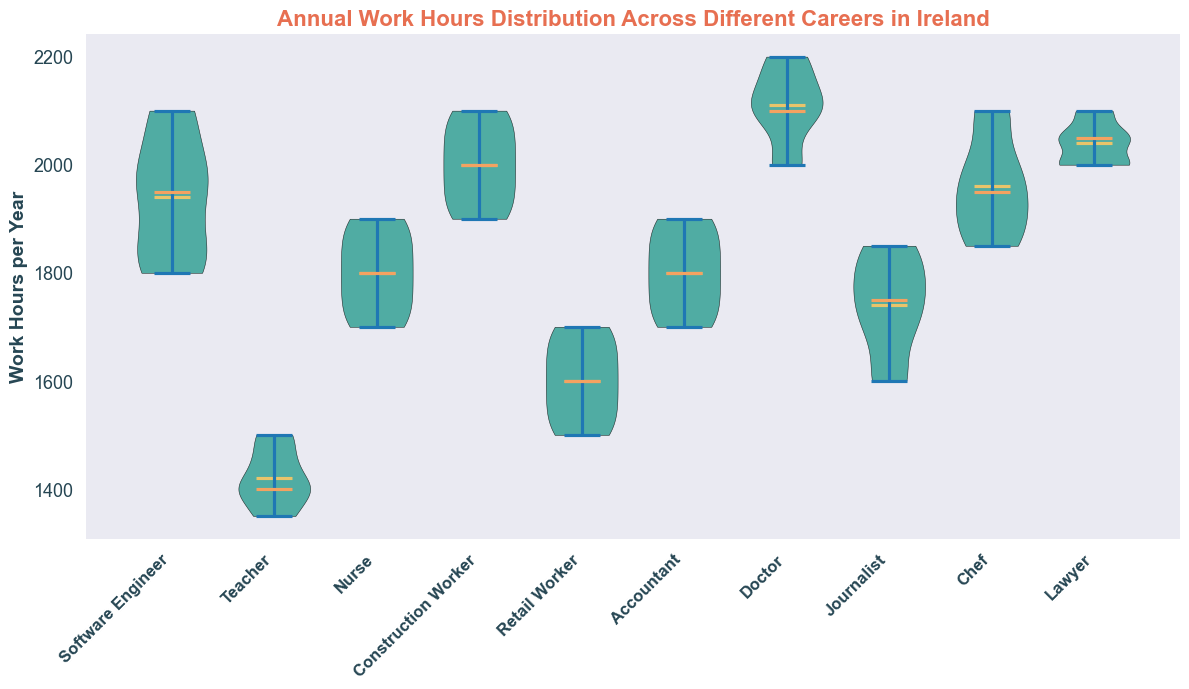Which career has the highest average annual work hours? To calculate the average, we can look at the distribution of the annual work hours for each career. The career with the highest distribution will likely have the highest average. From the plot, Doctors and Lawyers show the highest median lines and distributed work hours, indicating Doctors have the highest average.
Answer: Doctor Which career shows the most variation in annual work hours? We can examine the width and spread of each violin plot. The wider and more spread out the distribution, the greater the variation. From the plot, the distribution of Construction Workers and Doctors seem to show the most spread, indicating the most variation.
Answer: Construction Worker and Doctor What is the median annual work hours for Nurses? The median is shown by the orange line inside each violin plot. For Nurses, the median line intersects close to 1800 work hours per year.
Answer: 1800 Which career has the smallest average annual work hours? We assess the average by looking at the placement of the center of the distributions. Teachers appear to have the lowest central position, suggesting the smallest average annual work hours.
Answer: Teacher Between Teachers and Retail Workers, who works more annual hours on average? To compare, we look at the median lines. Retail Workers have a higher median line than Teachers, indicating Retail Workers work more on average.
Answer: Retail Worker How do the mean work hours for Accountants compare to those for Software Engineers? The mean is indicated by the yellow line within each violin plot. Comparing these lines, Software Engineers have a higher mean line than Accountants.
Answer: Software Engineers Which career groups have work hours distributions overlapping significantly? We look for violin plots that have the same range or significantly overlapping areas. The plots for Accountants and Software Engineers overlap significantly, indicating similar distributions.
Answer: Accountant and Software Engineer Is there a career where the middle 50% of the data (interquartile range) is very clustered? A narrow distribution around the center implies a clustered interquartile range. Teachers have a tightly clustered distribution, suggesting a very clustered interquartile range.
Answer: Teacher What is the interquartile range (IQR) for Construction Workers' annual work hours? The interquartile range can be estimated by the width of the violin plot around the median and quartiles. Construction Workers have work hours around 1900 to 2050, so the IQR is approximately 2050 - 1900.
Answer: 150 